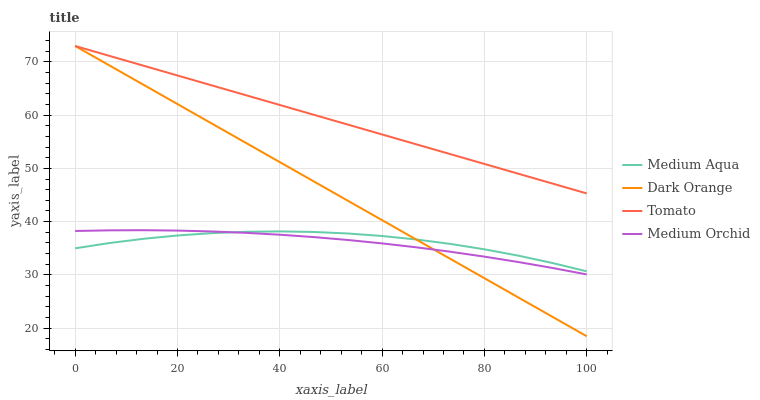Does Medium Orchid have the minimum area under the curve?
Answer yes or no. Yes. Does Tomato have the maximum area under the curve?
Answer yes or no. Yes. Does Dark Orange have the minimum area under the curve?
Answer yes or no. No. Does Dark Orange have the maximum area under the curve?
Answer yes or no. No. Is Tomato the smoothest?
Answer yes or no. Yes. Is Medium Aqua the roughest?
Answer yes or no. Yes. Is Dark Orange the smoothest?
Answer yes or no. No. Is Dark Orange the roughest?
Answer yes or no. No. Does Dark Orange have the lowest value?
Answer yes or no. Yes. Does Medium Orchid have the lowest value?
Answer yes or no. No. Does Dark Orange have the highest value?
Answer yes or no. Yes. Does Medium Orchid have the highest value?
Answer yes or no. No. Is Medium Aqua less than Tomato?
Answer yes or no. Yes. Is Tomato greater than Medium Orchid?
Answer yes or no. Yes. Does Dark Orange intersect Medium Aqua?
Answer yes or no. Yes. Is Dark Orange less than Medium Aqua?
Answer yes or no. No. Is Dark Orange greater than Medium Aqua?
Answer yes or no. No. Does Medium Aqua intersect Tomato?
Answer yes or no. No. 